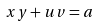Convert formula to latex. <formula><loc_0><loc_0><loc_500><loc_500>x y + u v = a</formula> 